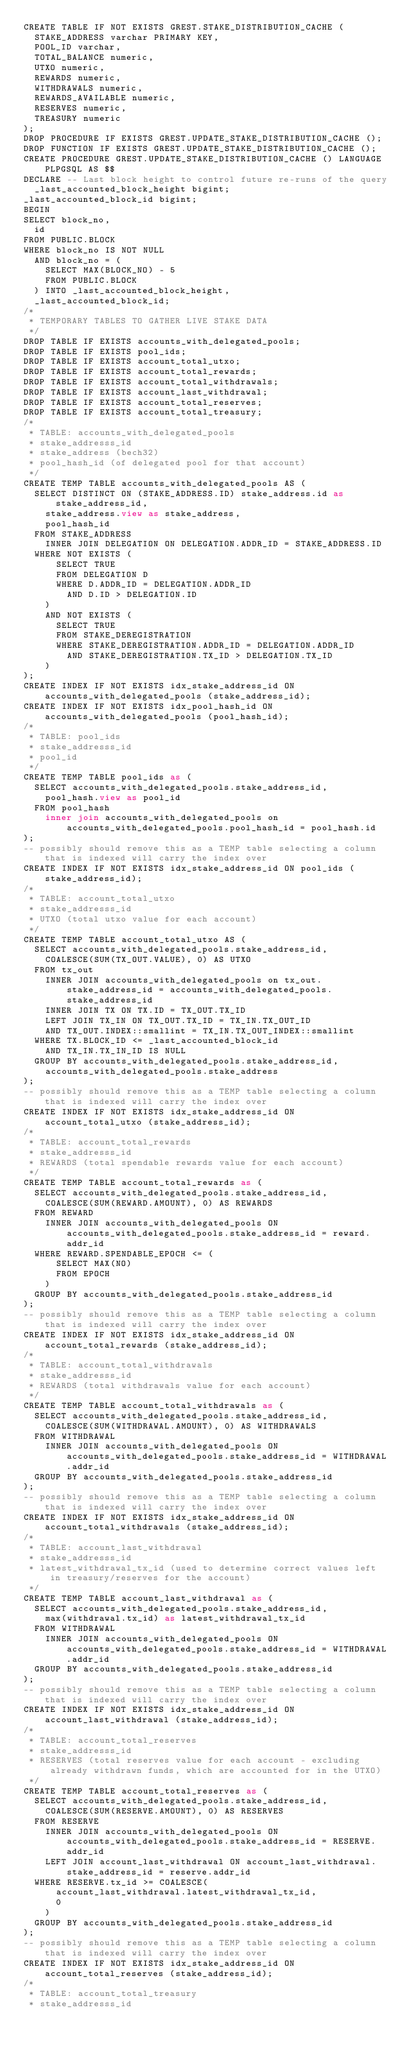Convert code to text. <code><loc_0><loc_0><loc_500><loc_500><_SQL_>CREATE TABLE IF NOT EXISTS GREST.STAKE_DISTRIBUTION_CACHE (
  STAKE_ADDRESS varchar PRIMARY KEY,
  POOL_ID varchar,
  TOTAL_BALANCE numeric,
  UTXO numeric,
  REWARDS numeric,
  WITHDRAWALS numeric,
  REWARDS_AVAILABLE numeric,
  RESERVES numeric,
  TREASURY numeric
);
DROP PROCEDURE IF EXISTS GREST.UPDATE_STAKE_DISTRIBUTION_CACHE ();
DROP FUNCTION IF EXISTS GREST.UPDATE_STAKE_DISTRIBUTION_CACHE ();
CREATE PROCEDURE GREST.UPDATE_STAKE_DISTRIBUTION_CACHE () LANGUAGE PLPGSQL AS $$
DECLARE -- Last block height to control future re-runs of the query
  _last_accounted_block_height bigint;
_last_accounted_block_id bigint;
BEGIN
SELECT block_no,
  id
FROM PUBLIC.BLOCK
WHERE block_no IS NOT NULL
  AND block_no = (
    SELECT MAX(BLOCK_NO) - 5
    FROM PUBLIC.BLOCK
  ) INTO _last_accounted_block_height,
  _last_accounted_block_id;
/* 
 * TEMPORARY TABLES TO GATHER LIVE STAKE DATA 
 */
DROP TABLE IF EXISTS accounts_with_delegated_pools;
DROP TABLE IF EXISTS pool_ids;
DROP TABLE IF EXISTS account_total_utxo;
DROP TABLE IF EXISTS account_total_rewards;
DROP TABLE IF EXISTS account_total_withdrawals;
DROP TABLE IF EXISTS account_last_withdrawal;
DROP TABLE IF EXISTS account_total_reserves;
DROP TABLE IF EXISTS account_total_treasury;
/* 
 * TABLE: accounts_with_delegated_pools
 * stake_addresss_id
 * stake_address (bech32)
 * pool_hash_id (of delegated pool for that account)
 */
CREATE TEMP TABLE accounts_with_delegated_pools AS (
  SELECT DISTINCT ON (STAKE_ADDRESS.ID) stake_address.id as stake_address_id,
    stake_address.view as stake_address,
    pool_hash_id
  FROM STAKE_ADDRESS
    INNER JOIN DELEGATION ON DELEGATION.ADDR_ID = STAKE_ADDRESS.ID
  WHERE NOT EXISTS (
      SELECT TRUE
      FROM DELEGATION D
      WHERE D.ADDR_ID = DELEGATION.ADDR_ID
        AND D.ID > DELEGATION.ID
    )
    AND NOT EXISTS (
      SELECT TRUE
      FROM STAKE_DEREGISTRATION
      WHERE STAKE_DEREGISTRATION.ADDR_ID = DELEGATION.ADDR_ID
        AND STAKE_DEREGISTRATION.TX_ID > DELEGATION.TX_ID
    )
);
CREATE INDEX IF NOT EXISTS idx_stake_address_id ON accounts_with_delegated_pools (stake_address_id);
CREATE INDEX IF NOT EXISTS idx_pool_hash_id ON accounts_with_delegated_pools (pool_hash_id);
/* 
 * TABLE: pool_ids
 * stake_addresss_id
 * pool_id
 */
CREATE TEMP TABLE pool_ids as (
  SELECT accounts_with_delegated_pools.stake_address_id,
    pool_hash.view as pool_id
  FROM pool_hash
    inner join accounts_with_delegated_pools on accounts_with_delegated_pools.pool_hash_id = pool_hash.id
);
-- possibly should remove this as a TEMP table selecting a column that is indexed will carry the index over
CREATE INDEX IF NOT EXISTS idx_stake_address_id ON pool_ids (stake_address_id);
/* 
 * TABLE: account_total_utxo
 * stake_addresss_id
 * UTXO (total utxo value for each account)
 */
CREATE TEMP TABLE account_total_utxo AS (
  SELECT accounts_with_delegated_pools.stake_address_id,
    COALESCE(SUM(TX_OUT.VALUE), 0) AS UTXO
  FROM tx_out
    INNER JOIN accounts_with_delegated_pools on tx_out.stake_address_id = accounts_with_delegated_pools.stake_address_id
    INNER JOIN TX ON TX.ID = TX_OUT.TX_ID
    LEFT JOIN TX_IN ON TX_OUT.TX_ID = TX_IN.TX_OUT_ID
    AND TX_OUT.INDEX::smallint = TX_IN.TX_OUT_INDEX::smallint
  WHERE TX.BLOCK_ID <= _last_accounted_block_id
    AND TX_IN.TX_IN_ID IS NULL
  GROUP BY accounts_with_delegated_pools.stake_address_id,
    accounts_with_delegated_pools.stake_address
);
-- possibly should remove this as a TEMP table selecting a column that is indexed will carry the index over
CREATE INDEX IF NOT EXISTS idx_stake_address_id ON account_total_utxo (stake_address_id);
/* 
 * TABLE: account_total_rewards
 * stake_addresss_id
 * REWARDS (total spendable rewards value for each account)
 */
CREATE TEMP TABLE account_total_rewards as (
  SELECT accounts_with_delegated_pools.stake_address_id,
    COALESCE(SUM(REWARD.AMOUNT), 0) AS REWARDS
  FROM REWARD
    INNER JOIN accounts_with_delegated_pools ON accounts_with_delegated_pools.stake_address_id = reward.addr_id
  WHERE REWARD.SPENDABLE_EPOCH <= (
      SELECT MAX(NO)
      FROM EPOCH
    )
  GROUP BY accounts_with_delegated_pools.stake_address_id
);
-- possibly should remove this as a TEMP table selecting a column that is indexed will carry the index over
CREATE INDEX IF NOT EXISTS idx_stake_address_id ON account_total_rewards (stake_address_id);
/* 
 * TABLE: account_total_withdrawals
 * stake_addresss_id
 * REWARDS (total withdrawals value for each account)
 */
CREATE TEMP TABLE account_total_withdrawals as (
  SELECT accounts_with_delegated_pools.stake_address_id,
    COALESCE(SUM(WITHDRAWAL.AMOUNT), 0) AS WITHDRAWALS
  FROM WITHDRAWAL
    INNER JOIN accounts_with_delegated_pools ON accounts_with_delegated_pools.stake_address_id = WITHDRAWAL.addr_id
  GROUP BY accounts_with_delegated_pools.stake_address_id
);
-- possibly should remove this as a TEMP table selecting a column that is indexed will carry the index over
CREATE INDEX IF NOT EXISTS idx_stake_address_id ON account_total_withdrawals (stake_address_id);
/* 
 * TABLE: account_last_withdrawal
 * stake_addresss_id
 * latest_withdrawal_tx_id (used to determine correct values left in treasury/reserves for the account)
 */
CREATE TEMP TABLE account_last_withdrawal as (
  SELECT accounts_with_delegated_pools.stake_address_id,
    max(withdrawal.tx_id) as latest_withdrawal_tx_id
  FROM WITHDRAWAL
    INNER JOIN accounts_with_delegated_pools ON accounts_with_delegated_pools.stake_address_id = WITHDRAWAL.addr_id
  GROUP BY accounts_with_delegated_pools.stake_address_id
);
-- possibly should remove this as a TEMP table selecting a column that is indexed will carry the index over
CREATE INDEX IF NOT EXISTS idx_stake_address_id ON account_last_withdrawal (stake_address_id);
/* 
 * TABLE: account_total_reserves
 * stake_addresss_id
 * RESERVES (total reserves value for each account - excluding already withdrawn funds, which are accounted for in the UTXO)
 */
CREATE TEMP TABLE account_total_reserves as (
  SELECT accounts_with_delegated_pools.stake_address_id,
    COALESCE(SUM(RESERVE.AMOUNT), 0) AS RESERVES
  FROM RESERVE
    INNER JOIN accounts_with_delegated_pools ON accounts_with_delegated_pools.stake_address_id = RESERVE.addr_id
    LEFT JOIN account_last_withdrawal ON account_last_withdrawal.stake_address_id = reserve.addr_id
  WHERE RESERVE.tx_id >= COALESCE(
      account_last_withdrawal.latest_withdrawal_tx_id,
      0
    )
  GROUP BY accounts_with_delegated_pools.stake_address_id
);
-- possibly should remove this as a TEMP table selecting a column that is indexed will carry the index over
CREATE INDEX IF NOT EXISTS idx_stake_address_id ON account_total_reserves (stake_address_id);
/* 
 * TABLE: account_total_treasury
 * stake_addresss_id</code> 